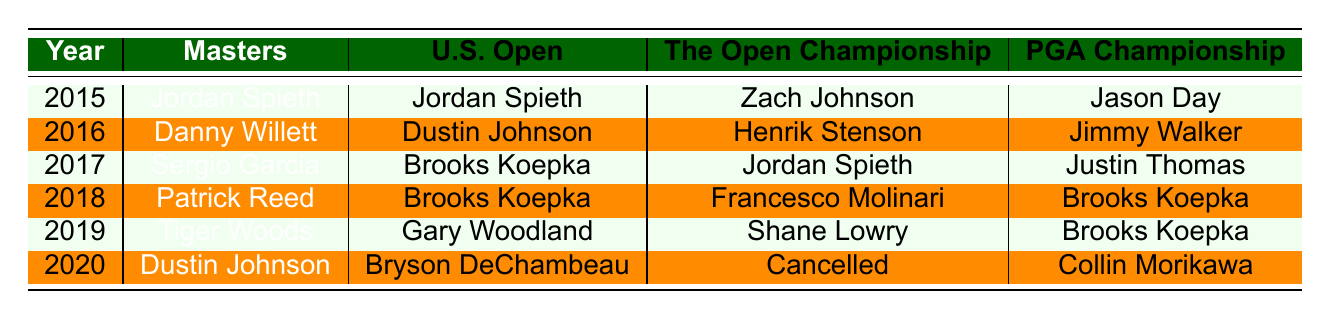What player won the Masters in 2019? Referring to the table, the entry for the Masters in the year 2019 states "Tiger Woods" as the winner.
Answer: Tiger Woods How many times did Brooks Koepka win between 2017 and 2019? From the table, Brooks Koepka won the U.S. Open in 2017 and 2018, and the PGA Championship in 2018 and 2019, totaling four wins.
Answer: Four Did Dustin Johnson win any major championships in 2016? Looking at the table, the column for each major in 2016 shows that Dustin Johnson did not win any, as his name does not appear in any of the categories for that year.
Answer: No What was the most recent major championship won by Jordan Spieth? In the table, Jordan Spieth won the Masters and U.S. Open in 2015 and the Open Championship in 2017. The most recent win is the Open Championship in 2017.
Answer: Open Championship in 2017 Which players won the PGA Championship in consecutive years? Analyzing the table, Brooks Koepka won the PGA Championship in 2018 and 2019. Therefore, he is the only player listed who won in consecutive years.
Answer: Brooks Koepka Was there a year where the Open Championship was cancelled? The table indicates that in 2020, the Open Championship was marked as "Cancelled," answering the question affirmatively.
Answer: Yes How many different players won the Masters from 2015 to 2020? By counting the unique winners in the Masters column from the table, we see the players are Jordan Spieth, Danny Willett, Sergio Garcia, Patrick Reed, Tiger Woods, and Dustin Johnson, totaling six different players.
Answer: Six In which year did Brooks Koepka win both the U.S. Open and the PGA Championship? The table shows that Brooks Koepka won the U.S. Open in both 2017 and 2018, and the PGA Championship in 2018, making 2018 the year he won both titles.
Answer: 2018 Who won the U.S. Open in 2020? The entry for the U.S. Open in 2020 identifies Bryson DeChambeau as the champion, as indicated in the table.
Answer: Bryson DeChambeau Which major championship had the last champion of this period? The table reveals that the last major listed for the year 2020 was won by Collin Morikawa in the PGA Championship. Therefore, the PGA Championship had the last champion.
Answer: PGA Championship List all the players who won the Open Championship from 2015 to 2020. From the table, the winners of the Open Championship from 2015 to 2020 are Zach Johnson, Henrik Stenson, Jordan Spieth, Francesco Molinari, Shane Lowry, and the championship was cancelled in 2020.
Answer: Zach Johnson, Henrik Stenson, Jordan Spieth, Francesco Molinari, Shane Lowry 